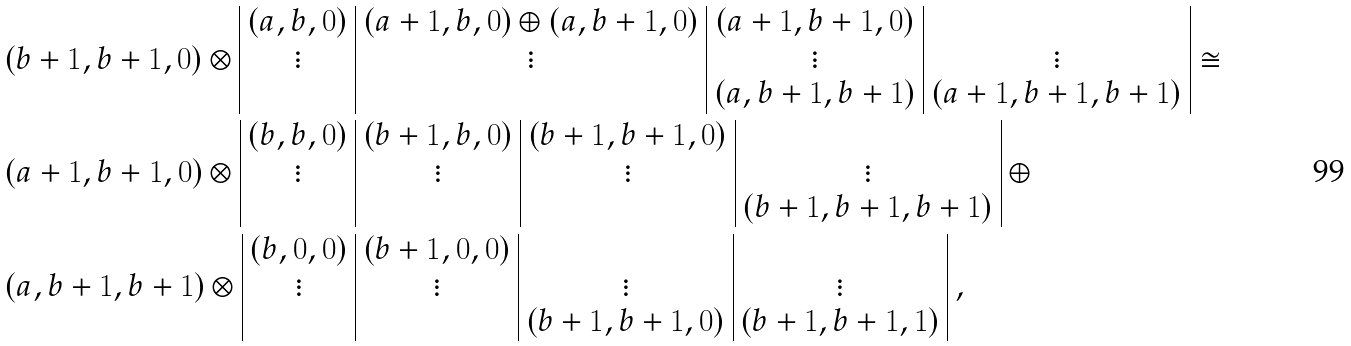<formula> <loc_0><loc_0><loc_500><loc_500>& ( b + 1 , b + 1 , 0 ) \otimes \begin{array} { | c | c | c | c | } ( a , b , 0 ) & ( a + 1 , b , 0 ) \oplus ( a , b + 1 , 0 ) & ( a + 1 , b + 1 , 0 ) & \\ \vdots & \vdots & \vdots & \vdots \\ & & ( a , b + 1 , b + 1 ) & ( a + 1 , b + 1 , b + 1 ) \\ \end{array} \cong \\ & ( a + 1 , b + 1 , 0 ) \otimes \begin{array} { | c | c | c | c | } ( b , b , 0 ) & ( b + 1 , b , 0 ) & ( b + 1 , b + 1 , 0 ) & \\ \vdots & \vdots & \vdots & \vdots \\ & & & ( b + 1 , b + 1 , b + 1 ) \\ \end{array} \ \oplus \\ & ( a , b + 1 , b + 1 ) \otimes \begin{array} { | c | c | c | c | } ( b , 0 , 0 ) & ( b + 1 , 0 , 0 ) & & \\ \vdots & \vdots & \vdots & \vdots \\ & & ( b + 1 , b + 1 , 0 ) & ( b + 1 , b + 1 , 1 ) \\ \end{array} \ ,</formula> 